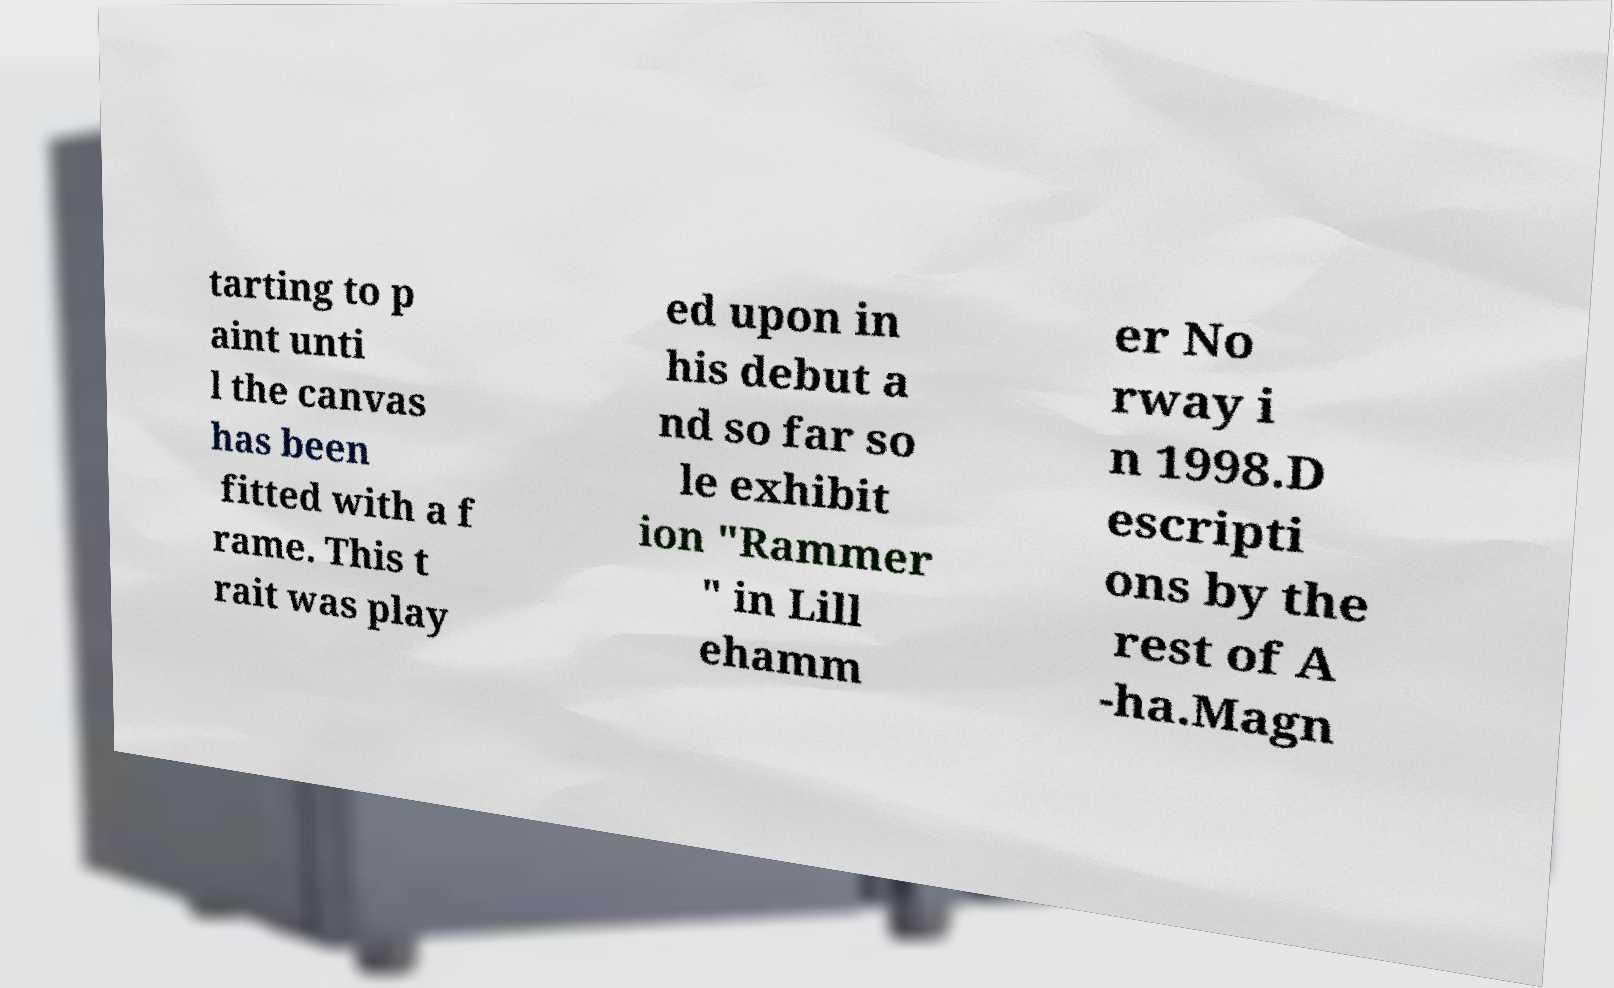There's text embedded in this image that I need extracted. Can you transcribe it verbatim? tarting to p aint unti l the canvas has been fitted with a f rame. This t rait was play ed upon in his debut a nd so far so le exhibit ion "Rammer " in Lill ehamm er No rway i n 1998.D escripti ons by the rest of A -ha.Magn 